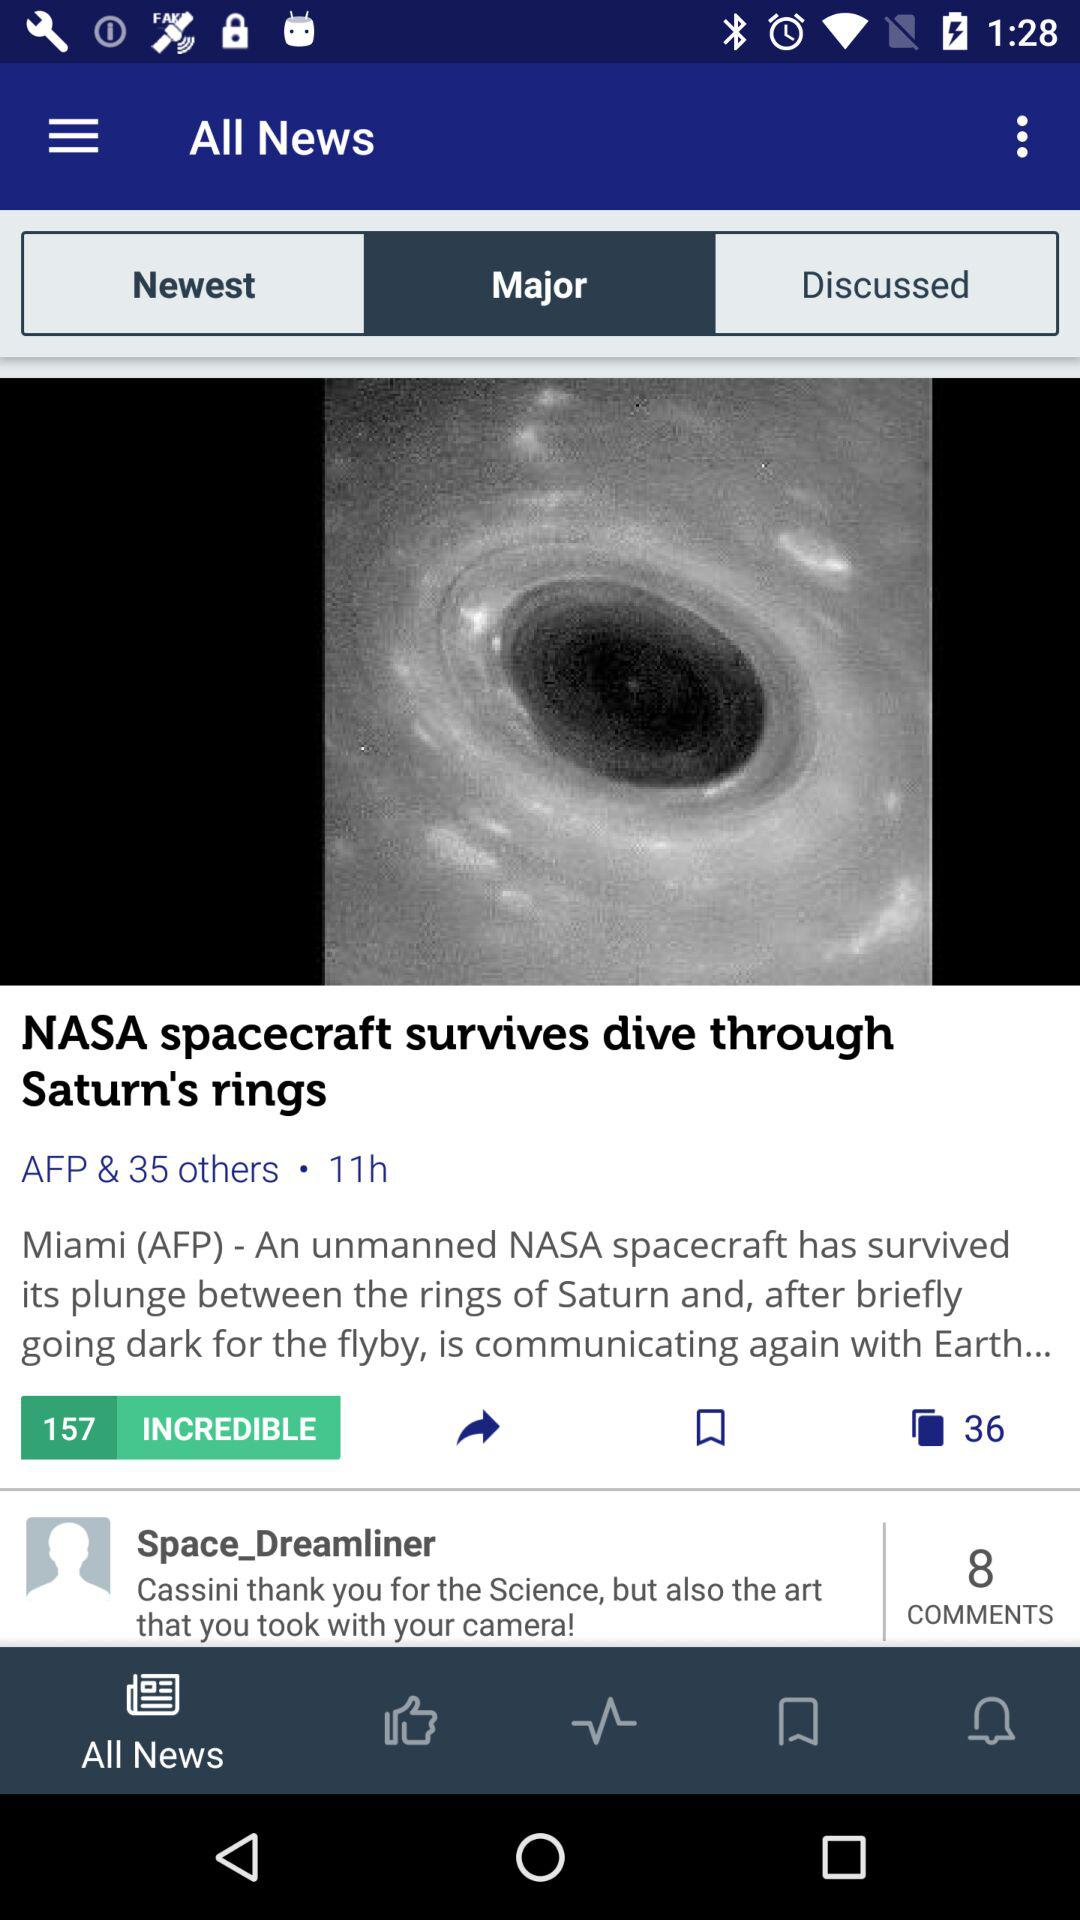When was the news "NASA spacecraft survives dive through Saturn's rings" posted? The news was posted 11 hours ago. 